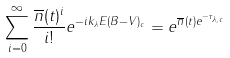<formula> <loc_0><loc_0><loc_500><loc_500>\sum _ { i = 0 } ^ { \infty } \frac { \overline { n } ( t ) ^ { i } } { i ! } e ^ { - i k _ { \lambda } E ( B - V ) _ { c } } = e ^ { \overline { n } ( t ) e ^ { - \tau _ { \lambda , c } } }</formula> 